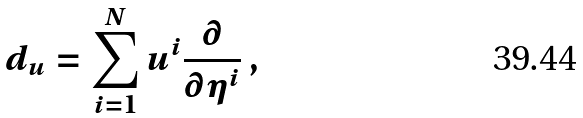Convert formula to latex. <formula><loc_0><loc_0><loc_500><loc_500>d _ { u } = \sum _ { i = 1 } ^ { N } u ^ { i } \frac { \partial } { \partial \eta ^ { i } } \, ,</formula> 